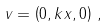Convert formula to latex. <formula><loc_0><loc_0><loc_500><loc_500>v = \left ( 0 , k x , 0 \right ) \, ,</formula> 